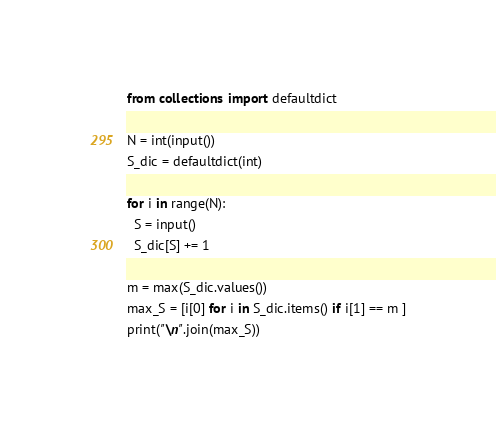<code> <loc_0><loc_0><loc_500><loc_500><_Python_>from collections import defaultdict

N = int(input())
S_dic = defaultdict(int)

for i in range(N):
  S = input()
  S_dic[S] += 1

m = max(S_dic.values())
max_S = [i[0] for i in S_dic.items() if i[1] == m ]
print("\n".join(max_S))</code> 